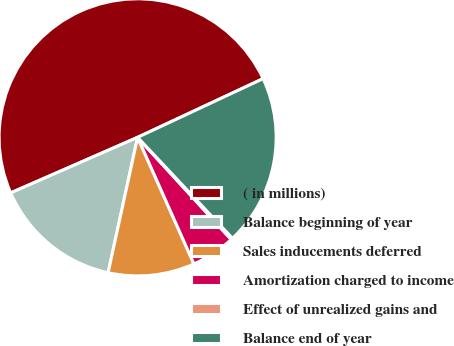<chart> <loc_0><loc_0><loc_500><loc_500><pie_chart><fcel>( in millions)<fcel>Balance beginning of year<fcel>Sales inducements deferred<fcel>Amortization charged to income<fcel>Effect of unrealized gains and<fcel>Balance end of year<nl><fcel>49.61%<fcel>15.02%<fcel>10.08%<fcel>5.14%<fcel>0.2%<fcel>19.96%<nl></chart> 